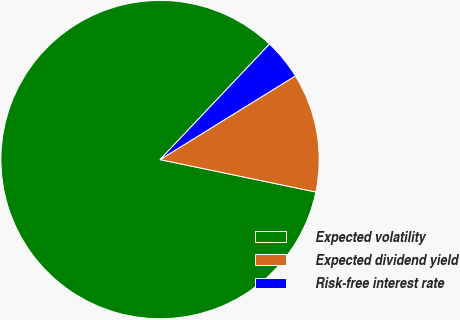<chart> <loc_0><loc_0><loc_500><loc_500><pie_chart><fcel>Expected volatility<fcel>Expected dividend yield<fcel>Risk-free interest rate<nl><fcel>83.81%<fcel>12.08%<fcel>4.11%<nl></chart> 